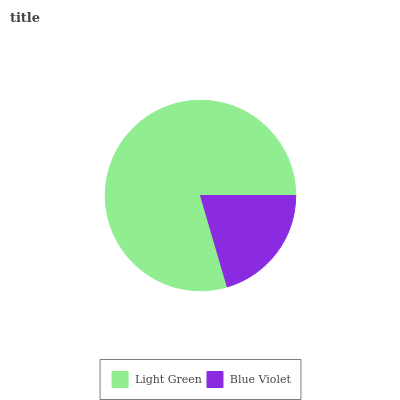Is Blue Violet the minimum?
Answer yes or no. Yes. Is Light Green the maximum?
Answer yes or no. Yes. Is Blue Violet the maximum?
Answer yes or no. No. Is Light Green greater than Blue Violet?
Answer yes or no. Yes. Is Blue Violet less than Light Green?
Answer yes or no. Yes. Is Blue Violet greater than Light Green?
Answer yes or no. No. Is Light Green less than Blue Violet?
Answer yes or no. No. Is Light Green the high median?
Answer yes or no. Yes. Is Blue Violet the low median?
Answer yes or no. Yes. Is Blue Violet the high median?
Answer yes or no. No. Is Light Green the low median?
Answer yes or no. No. 